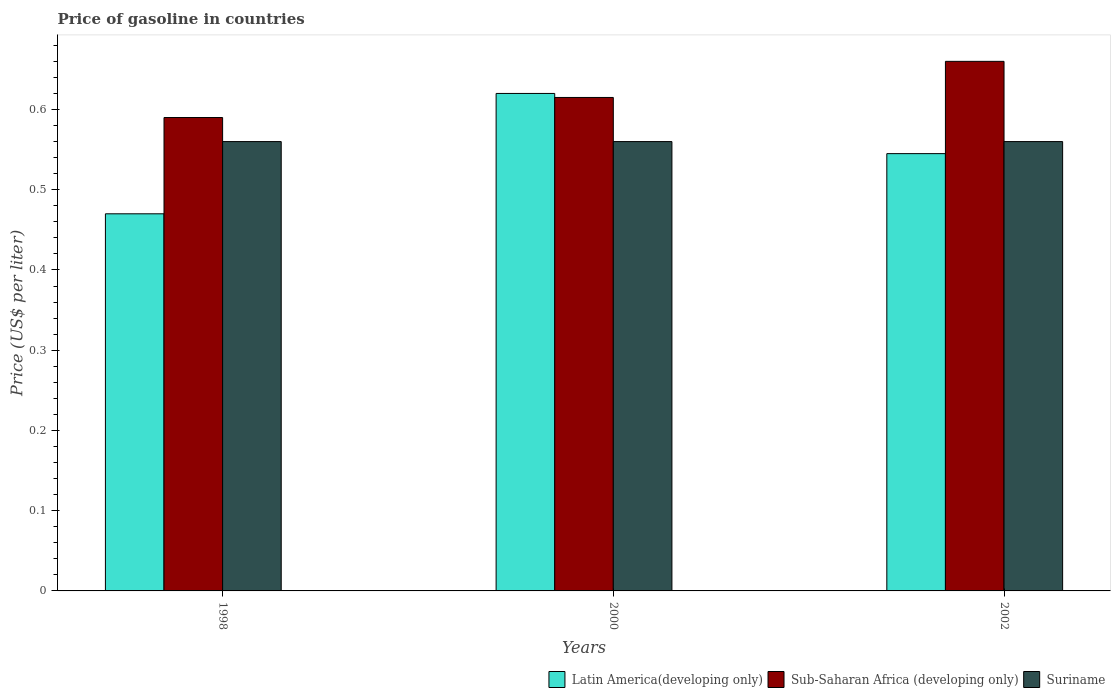How many different coloured bars are there?
Offer a very short reply. 3. How many bars are there on the 2nd tick from the left?
Your answer should be very brief. 3. What is the price of gasoline in Sub-Saharan Africa (developing only) in 1998?
Your answer should be compact. 0.59. Across all years, what is the maximum price of gasoline in Latin America(developing only)?
Give a very brief answer. 0.62. Across all years, what is the minimum price of gasoline in Latin America(developing only)?
Provide a succinct answer. 0.47. In which year was the price of gasoline in Sub-Saharan Africa (developing only) minimum?
Offer a terse response. 1998. What is the total price of gasoline in Latin America(developing only) in the graph?
Offer a terse response. 1.63. What is the difference between the price of gasoline in Suriname in 1998 and that in 2002?
Ensure brevity in your answer.  0. What is the difference between the price of gasoline in Sub-Saharan Africa (developing only) in 2000 and the price of gasoline in Latin America(developing only) in 2002?
Offer a terse response. 0.07. What is the average price of gasoline in Sub-Saharan Africa (developing only) per year?
Ensure brevity in your answer.  0.62. In the year 2000, what is the difference between the price of gasoline in Latin America(developing only) and price of gasoline in Sub-Saharan Africa (developing only)?
Your response must be concise. 0.01. What is the ratio of the price of gasoline in Latin America(developing only) in 1998 to that in 2002?
Offer a very short reply. 0.86. Is the price of gasoline in Latin America(developing only) in 1998 less than that in 2000?
Your answer should be very brief. Yes. What is the difference between the highest and the second highest price of gasoline in Latin America(developing only)?
Offer a terse response. 0.07. What does the 1st bar from the left in 2000 represents?
Make the answer very short. Latin America(developing only). What does the 2nd bar from the right in 2002 represents?
Give a very brief answer. Sub-Saharan Africa (developing only). Is it the case that in every year, the sum of the price of gasoline in Sub-Saharan Africa (developing only) and price of gasoline in Latin America(developing only) is greater than the price of gasoline in Suriname?
Provide a short and direct response. Yes. How many years are there in the graph?
Give a very brief answer. 3. What is the difference between two consecutive major ticks on the Y-axis?
Offer a very short reply. 0.1. Are the values on the major ticks of Y-axis written in scientific E-notation?
Make the answer very short. No. How many legend labels are there?
Offer a very short reply. 3. How are the legend labels stacked?
Your response must be concise. Horizontal. What is the title of the graph?
Your answer should be compact. Price of gasoline in countries. What is the label or title of the X-axis?
Provide a succinct answer. Years. What is the label or title of the Y-axis?
Offer a very short reply. Price (US$ per liter). What is the Price (US$ per liter) of Latin America(developing only) in 1998?
Ensure brevity in your answer.  0.47. What is the Price (US$ per liter) in Sub-Saharan Africa (developing only) in 1998?
Your answer should be very brief. 0.59. What is the Price (US$ per liter) in Suriname in 1998?
Make the answer very short. 0.56. What is the Price (US$ per liter) in Latin America(developing only) in 2000?
Provide a succinct answer. 0.62. What is the Price (US$ per liter) of Sub-Saharan Africa (developing only) in 2000?
Your answer should be compact. 0.61. What is the Price (US$ per liter) of Suriname in 2000?
Ensure brevity in your answer.  0.56. What is the Price (US$ per liter) in Latin America(developing only) in 2002?
Offer a terse response. 0.55. What is the Price (US$ per liter) in Sub-Saharan Africa (developing only) in 2002?
Keep it short and to the point. 0.66. What is the Price (US$ per liter) in Suriname in 2002?
Your answer should be compact. 0.56. Across all years, what is the maximum Price (US$ per liter) of Latin America(developing only)?
Give a very brief answer. 0.62. Across all years, what is the maximum Price (US$ per liter) in Sub-Saharan Africa (developing only)?
Make the answer very short. 0.66. Across all years, what is the maximum Price (US$ per liter) of Suriname?
Ensure brevity in your answer.  0.56. Across all years, what is the minimum Price (US$ per liter) in Latin America(developing only)?
Your response must be concise. 0.47. Across all years, what is the minimum Price (US$ per liter) of Sub-Saharan Africa (developing only)?
Keep it short and to the point. 0.59. Across all years, what is the minimum Price (US$ per liter) in Suriname?
Your answer should be compact. 0.56. What is the total Price (US$ per liter) of Latin America(developing only) in the graph?
Provide a short and direct response. 1.64. What is the total Price (US$ per liter) of Sub-Saharan Africa (developing only) in the graph?
Keep it short and to the point. 1.86. What is the total Price (US$ per liter) of Suriname in the graph?
Keep it short and to the point. 1.68. What is the difference between the Price (US$ per liter) of Latin America(developing only) in 1998 and that in 2000?
Provide a succinct answer. -0.15. What is the difference between the Price (US$ per liter) of Sub-Saharan Africa (developing only) in 1998 and that in 2000?
Provide a succinct answer. -0.03. What is the difference between the Price (US$ per liter) in Latin America(developing only) in 1998 and that in 2002?
Your answer should be compact. -0.07. What is the difference between the Price (US$ per liter) in Sub-Saharan Africa (developing only) in 1998 and that in 2002?
Offer a very short reply. -0.07. What is the difference between the Price (US$ per liter) of Latin America(developing only) in 2000 and that in 2002?
Make the answer very short. 0.07. What is the difference between the Price (US$ per liter) of Sub-Saharan Africa (developing only) in 2000 and that in 2002?
Offer a very short reply. -0.04. What is the difference between the Price (US$ per liter) of Latin America(developing only) in 1998 and the Price (US$ per liter) of Sub-Saharan Africa (developing only) in 2000?
Give a very brief answer. -0.14. What is the difference between the Price (US$ per liter) in Latin America(developing only) in 1998 and the Price (US$ per liter) in Suriname in 2000?
Your response must be concise. -0.09. What is the difference between the Price (US$ per liter) in Sub-Saharan Africa (developing only) in 1998 and the Price (US$ per liter) in Suriname in 2000?
Your answer should be very brief. 0.03. What is the difference between the Price (US$ per liter) in Latin America(developing only) in 1998 and the Price (US$ per liter) in Sub-Saharan Africa (developing only) in 2002?
Keep it short and to the point. -0.19. What is the difference between the Price (US$ per liter) in Latin America(developing only) in 1998 and the Price (US$ per liter) in Suriname in 2002?
Offer a very short reply. -0.09. What is the difference between the Price (US$ per liter) of Sub-Saharan Africa (developing only) in 1998 and the Price (US$ per liter) of Suriname in 2002?
Provide a succinct answer. 0.03. What is the difference between the Price (US$ per liter) in Latin America(developing only) in 2000 and the Price (US$ per liter) in Sub-Saharan Africa (developing only) in 2002?
Your answer should be compact. -0.04. What is the difference between the Price (US$ per liter) of Latin America(developing only) in 2000 and the Price (US$ per liter) of Suriname in 2002?
Make the answer very short. 0.06. What is the difference between the Price (US$ per liter) of Sub-Saharan Africa (developing only) in 2000 and the Price (US$ per liter) of Suriname in 2002?
Provide a succinct answer. 0.06. What is the average Price (US$ per liter) of Latin America(developing only) per year?
Provide a succinct answer. 0.55. What is the average Price (US$ per liter) in Sub-Saharan Africa (developing only) per year?
Provide a succinct answer. 0.62. What is the average Price (US$ per liter) of Suriname per year?
Your answer should be compact. 0.56. In the year 1998, what is the difference between the Price (US$ per liter) of Latin America(developing only) and Price (US$ per liter) of Sub-Saharan Africa (developing only)?
Provide a short and direct response. -0.12. In the year 1998, what is the difference between the Price (US$ per liter) in Latin America(developing only) and Price (US$ per liter) in Suriname?
Provide a short and direct response. -0.09. In the year 1998, what is the difference between the Price (US$ per liter) of Sub-Saharan Africa (developing only) and Price (US$ per liter) of Suriname?
Your answer should be very brief. 0.03. In the year 2000, what is the difference between the Price (US$ per liter) of Latin America(developing only) and Price (US$ per liter) of Sub-Saharan Africa (developing only)?
Make the answer very short. 0.01. In the year 2000, what is the difference between the Price (US$ per liter) in Sub-Saharan Africa (developing only) and Price (US$ per liter) in Suriname?
Your answer should be compact. 0.06. In the year 2002, what is the difference between the Price (US$ per liter) in Latin America(developing only) and Price (US$ per liter) in Sub-Saharan Africa (developing only)?
Make the answer very short. -0.12. In the year 2002, what is the difference between the Price (US$ per liter) in Latin America(developing only) and Price (US$ per liter) in Suriname?
Ensure brevity in your answer.  -0.01. What is the ratio of the Price (US$ per liter) in Latin America(developing only) in 1998 to that in 2000?
Keep it short and to the point. 0.76. What is the ratio of the Price (US$ per liter) in Sub-Saharan Africa (developing only) in 1998 to that in 2000?
Make the answer very short. 0.96. What is the ratio of the Price (US$ per liter) in Suriname in 1998 to that in 2000?
Give a very brief answer. 1. What is the ratio of the Price (US$ per liter) of Latin America(developing only) in 1998 to that in 2002?
Give a very brief answer. 0.86. What is the ratio of the Price (US$ per liter) of Sub-Saharan Africa (developing only) in 1998 to that in 2002?
Keep it short and to the point. 0.89. What is the ratio of the Price (US$ per liter) of Latin America(developing only) in 2000 to that in 2002?
Provide a succinct answer. 1.14. What is the ratio of the Price (US$ per liter) of Sub-Saharan Africa (developing only) in 2000 to that in 2002?
Provide a short and direct response. 0.93. What is the ratio of the Price (US$ per liter) in Suriname in 2000 to that in 2002?
Offer a terse response. 1. What is the difference between the highest and the second highest Price (US$ per liter) in Latin America(developing only)?
Your answer should be very brief. 0.07. What is the difference between the highest and the second highest Price (US$ per liter) in Sub-Saharan Africa (developing only)?
Ensure brevity in your answer.  0.04. What is the difference between the highest and the second highest Price (US$ per liter) of Suriname?
Offer a terse response. 0. What is the difference between the highest and the lowest Price (US$ per liter) in Latin America(developing only)?
Your answer should be very brief. 0.15. What is the difference between the highest and the lowest Price (US$ per liter) of Sub-Saharan Africa (developing only)?
Make the answer very short. 0.07. 